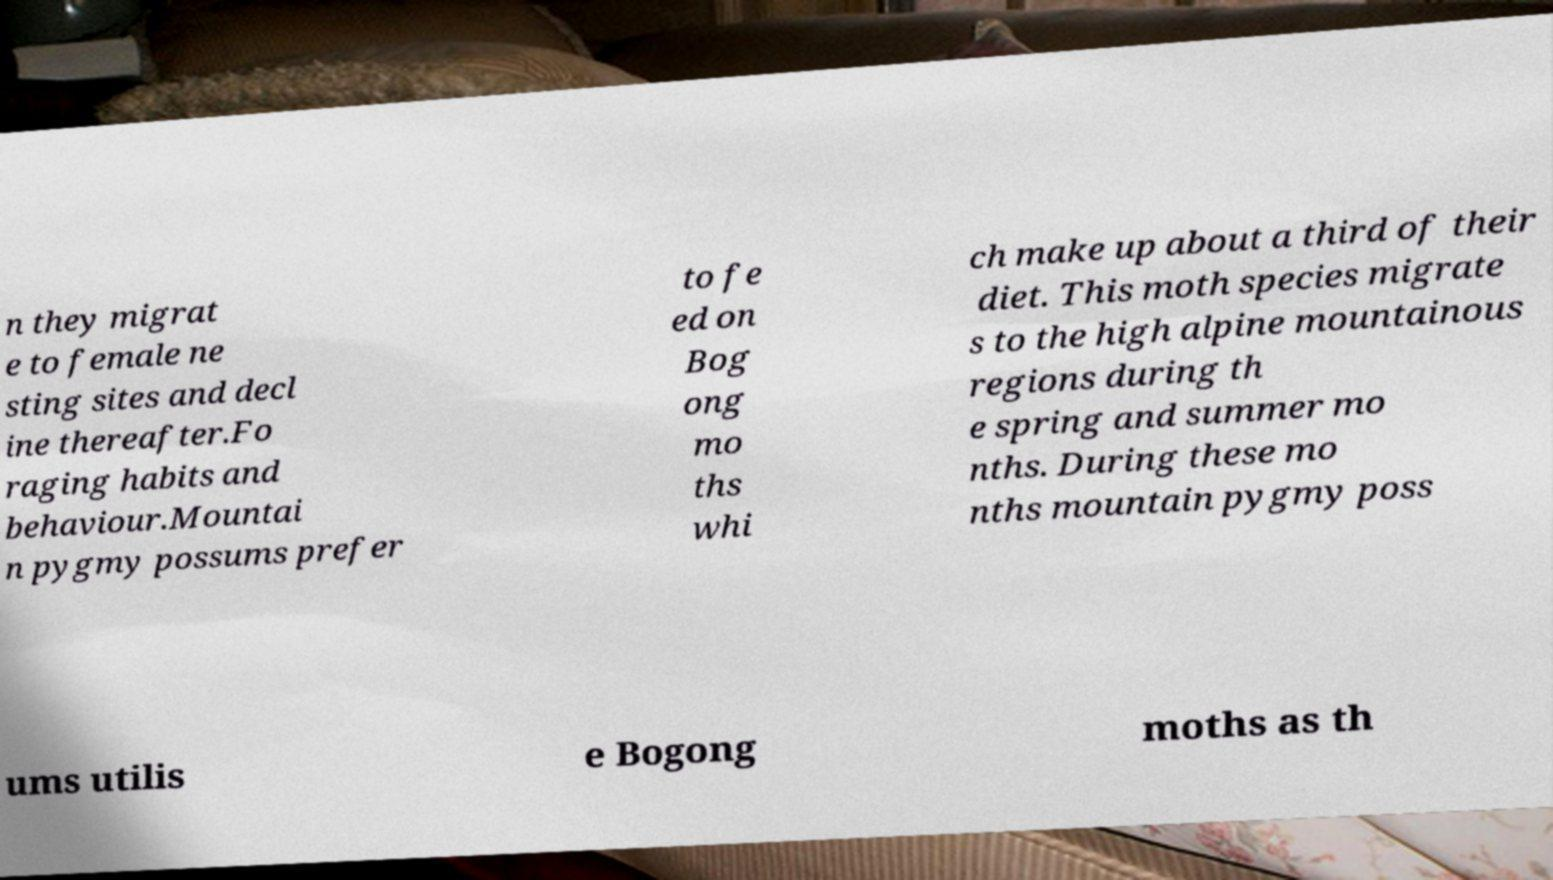Can you read and provide the text displayed in the image?This photo seems to have some interesting text. Can you extract and type it out for me? n they migrat e to female ne sting sites and decl ine thereafter.Fo raging habits and behaviour.Mountai n pygmy possums prefer to fe ed on Bog ong mo ths whi ch make up about a third of their diet. This moth species migrate s to the high alpine mountainous regions during th e spring and summer mo nths. During these mo nths mountain pygmy poss ums utilis e Bogong moths as th 